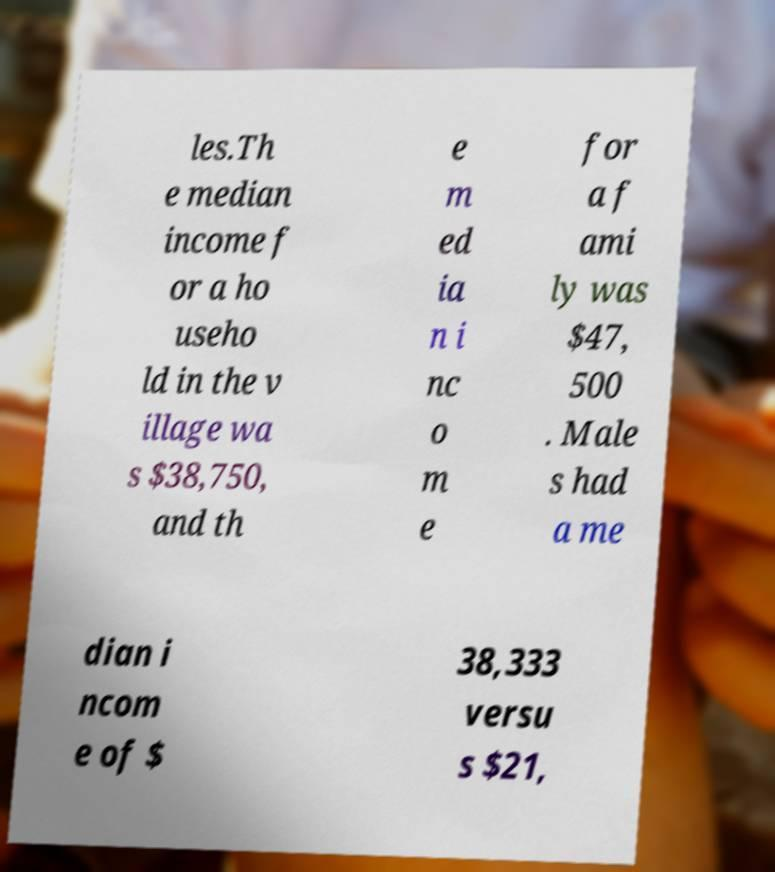I need the written content from this picture converted into text. Can you do that? les.Th e median income f or a ho useho ld in the v illage wa s $38,750, and th e m ed ia n i nc o m e for a f ami ly was $47, 500 . Male s had a me dian i ncom e of $ 38,333 versu s $21, 